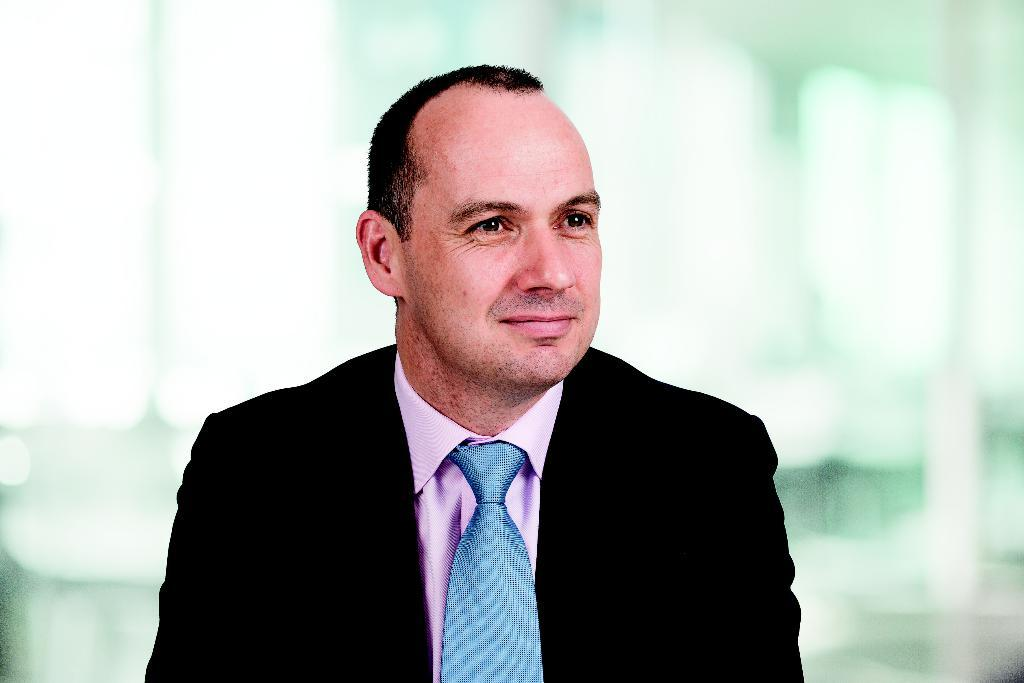What is present in the image? There is a man in the image. How is the man's expression in the image? The man is smiling in the image. What type of bean is being used as a prop in the image? There is no bean present in the image. Is the man walking in the rain in the image? There is no indication of rain or the man walking in the image. 